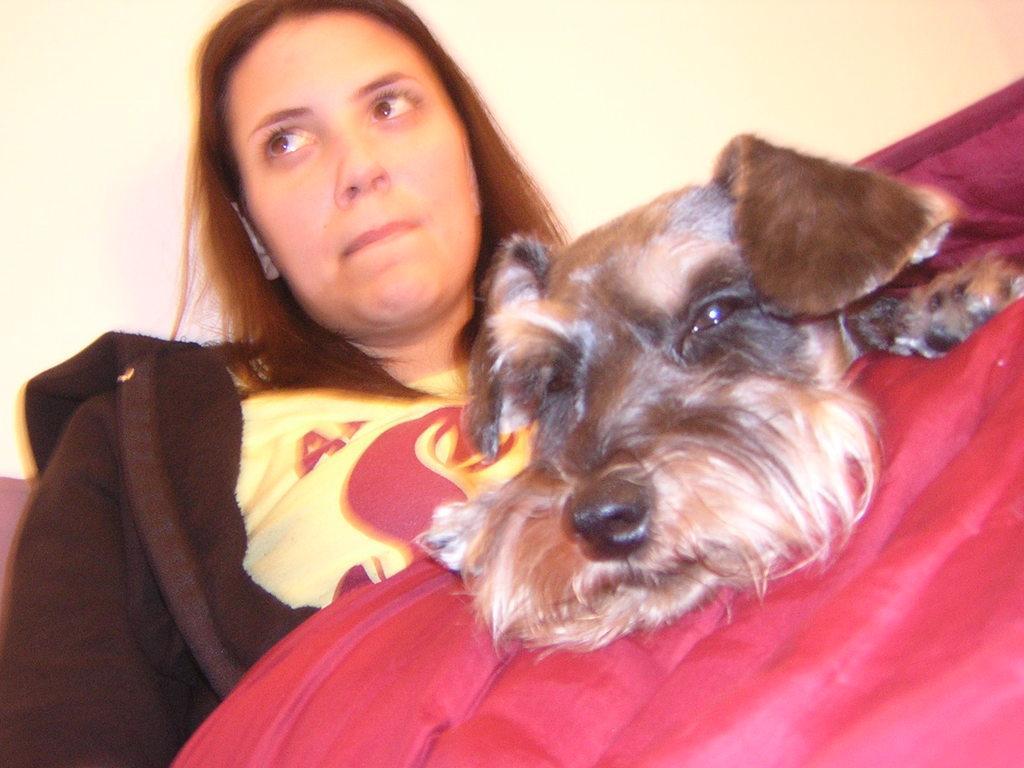Could you give a brief overview of what you see in this image? In this image we can see a woman. We can also see the red color blocked and also the dog. In the background there is plain wall. 